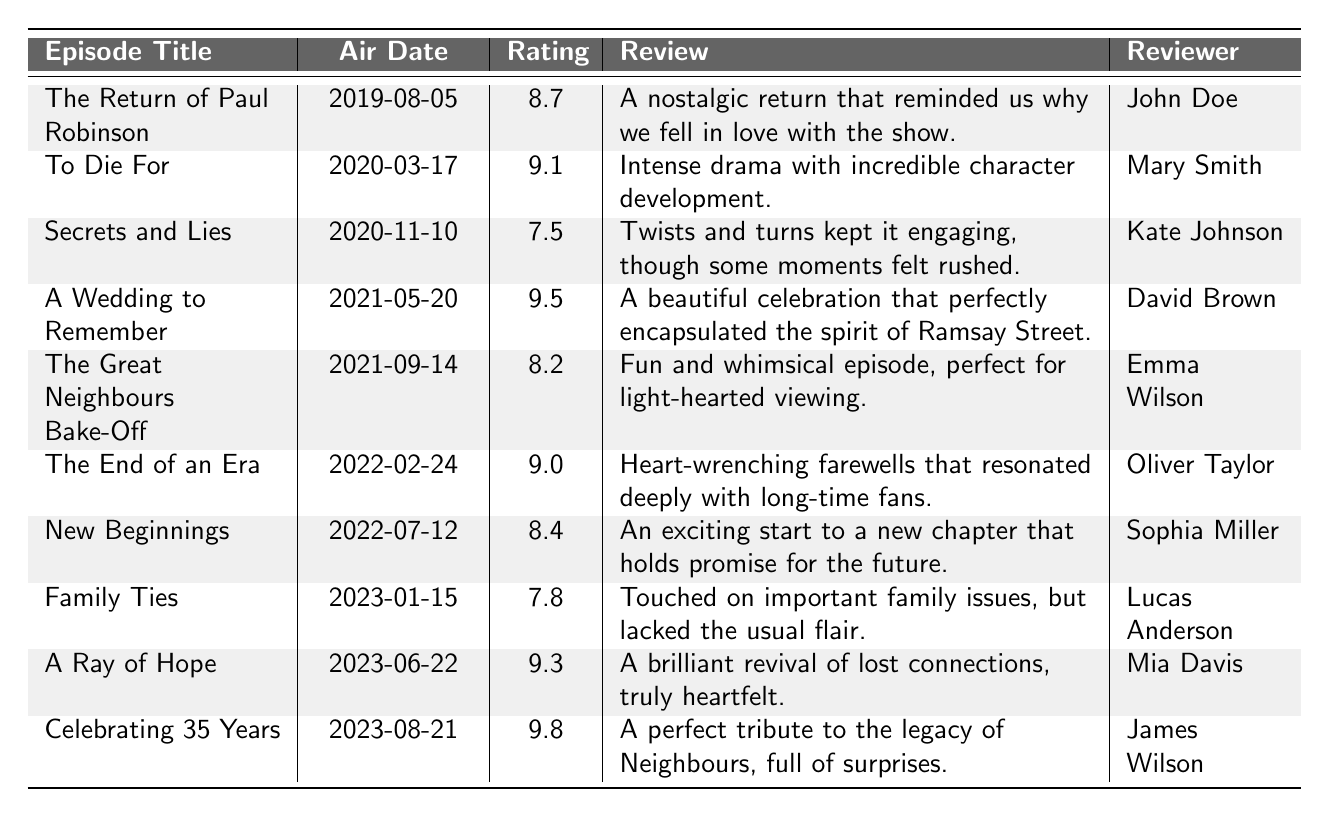What is the rating of "A Wedding to Remember"? The table lists "A Wedding to Remember" with a rating of 9.5.
Answer: 9.5 Which episode received the lowest rating in the last 5 years? The episode "Secrets and Lies" received the lowest rating of 7.5.
Answer: 7.5 What is the average rating of all episodes listed? The ratings are 8.7, 9.1, 7.5, 9.5, 8.2, 9.0, 8.4, 7.8, 9.3, and 9.8. The sum is 88.3, and there are 10 episodes, so the average rating is 88.3/10 = 8.83.
Answer: 8.83 Which episode has the review that mentions "heart-wrenching farewells"? The review mentioning "heart-wrenching farewells" is for "The End of an Era".
Answer: The End of an Era Did any episode receive a rating higher than 9.5? No, the highest rating is 9.8 for "Celebrating 35 Years".
Answer: No Which reviewers gave a rating of 9.0 or above? The reviewers for episodes with ratings of 9.0 or above are Mary Smith (9.1), David Brown (9.5), Oliver Taylor (9.0), Mia Davis (9.3), and James Wilson (9.8).
Answer: 5 reviewers How many episodes aired in 2022? The episodes "The End of an Era", "New Beginnings" aired in 2022; thus, there are two episodes in that year.
Answer: 2 What was the general sentiment for the episode "Family Ties"? The review for "Family Ties" mentions it touched on important family issues but lacked the usual flair, indicating a mixed sentiment.
Answer: Mixed sentiment Which episode had the most positive review? "Celebrating 35 Years" had the most positive review, being described as a "perfect tribute" to the legacy of Neighbours.
Answer: Celebrating 35 Years Calculate the difference in ratings between the highest-rated and lowest-rated episodes. The highest-rated episode is "Celebrating 35 Years" with a rating of 9.8 and the lowest is "Secrets and Lies" with a rating of 7.5. The difference is 9.8 - 7.5 = 2.3.
Answer: 2.3 